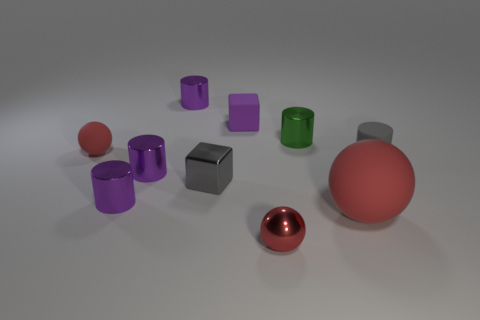Do the tiny matte ball and the tiny metallic ball have the same color?
Offer a terse response. Yes. What is the material of the small block that is behind the red matte ball on the left side of the large matte sphere?
Provide a short and direct response. Rubber. Is the size of the gray metal thing that is left of the red metal ball the same as the purple matte object?
Provide a succinct answer. Yes. The tiny gray rubber object that is in front of the rubber sphere that is on the left side of the tiny gray object on the left side of the large sphere is what shape?
Your answer should be very brief. Cylinder. How many things are red matte balls or purple objects behind the gray matte thing?
Give a very brief answer. 4. What is the size of the sphere that is behind the matte cylinder?
Offer a terse response. Small. What shape is the other rubber object that is the same color as the large object?
Ensure brevity in your answer.  Sphere. Is the material of the big thing the same as the tiny red thing to the right of the tiny red rubber thing?
Provide a short and direct response. No. What number of matte objects are in front of the matte sphere to the left of the small red thing in front of the tiny gray shiny thing?
Provide a short and direct response. 2. How many red objects are either tiny things or matte blocks?
Provide a short and direct response. 2. 